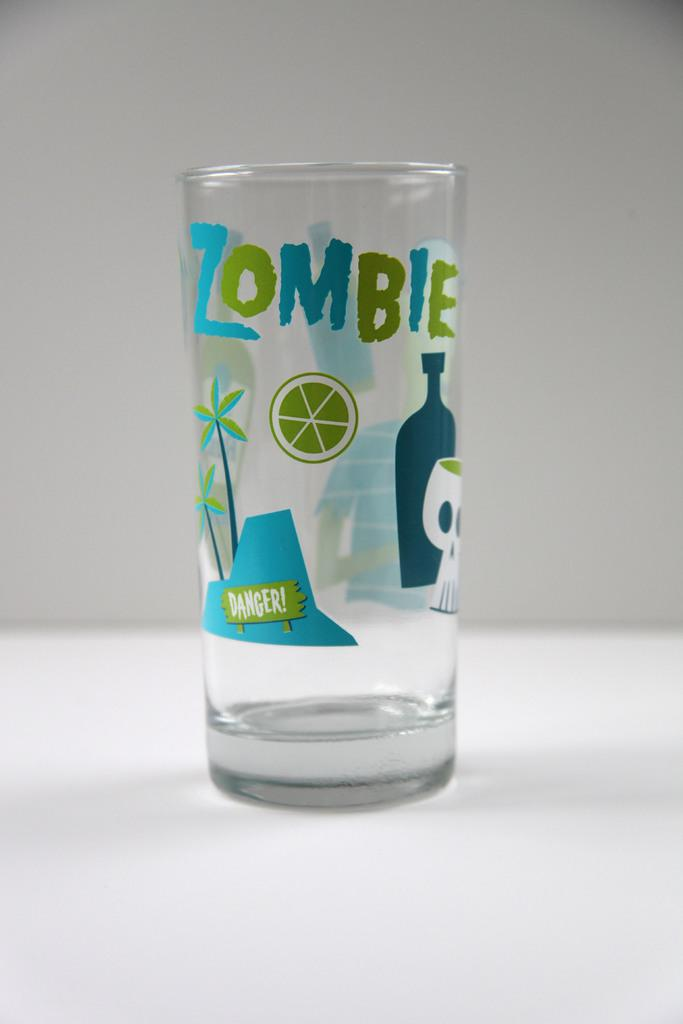<image>
Summarize the visual content of the image. A glass says Zombie and Danger! and has pictures of palm trees, a lime, and a skull. 